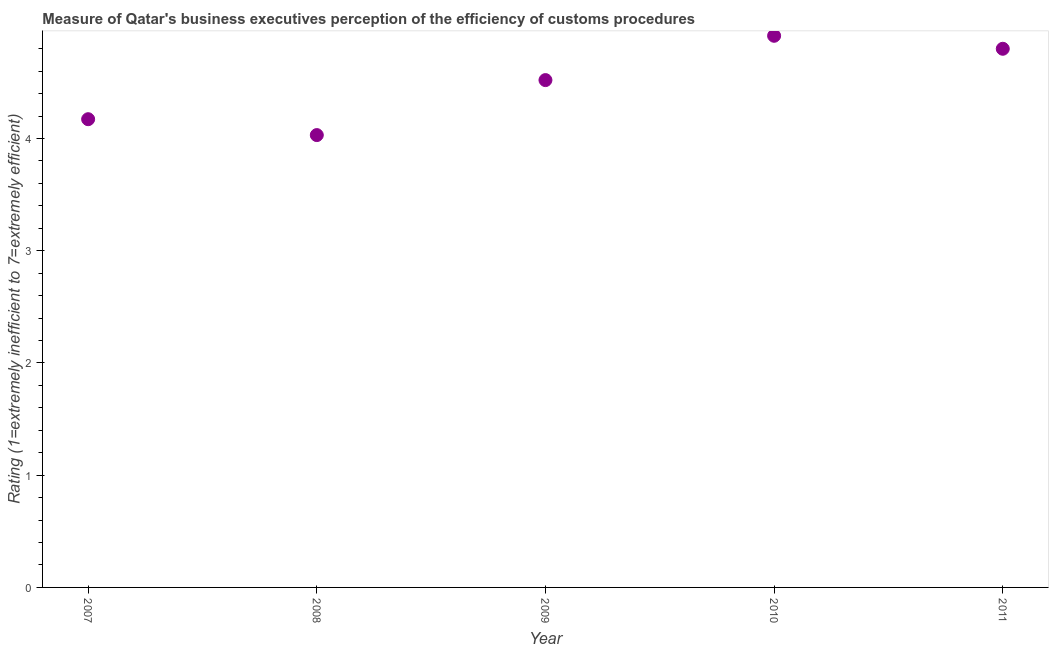What is the rating measuring burden of customs procedure in 2009?
Your answer should be very brief. 4.52. Across all years, what is the maximum rating measuring burden of customs procedure?
Give a very brief answer. 4.92. Across all years, what is the minimum rating measuring burden of customs procedure?
Ensure brevity in your answer.  4.03. In which year was the rating measuring burden of customs procedure minimum?
Keep it short and to the point. 2008. What is the sum of the rating measuring burden of customs procedure?
Ensure brevity in your answer.  22.44. What is the difference between the rating measuring burden of customs procedure in 2007 and 2010?
Provide a succinct answer. -0.74. What is the average rating measuring burden of customs procedure per year?
Give a very brief answer. 4.49. What is the median rating measuring burden of customs procedure?
Provide a succinct answer. 4.52. In how many years, is the rating measuring burden of customs procedure greater than 0.8 ?
Provide a short and direct response. 5. What is the ratio of the rating measuring burden of customs procedure in 2007 to that in 2011?
Keep it short and to the point. 0.87. Is the rating measuring burden of customs procedure in 2009 less than that in 2010?
Your response must be concise. Yes. What is the difference between the highest and the second highest rating measuring burden of customs procedure?
Your answer should be compact. 0.12. Is the sum of the rating measuring burden of customs procedure in 2007 and 2011 greater than the maximum rating measuring burden of customs procedure across all years?
Your answer should be very brief. Yes. What is the difference between the highest and the lowest rating measuring burden of customs procedure?
Your answer should be very brief. 0.88. Does the rating measuring burden of customs procedure monotonically increase over the years?
Keep it short and to the point. No. What is the difference between two consecutive major ticks on the Y-axis?
Offer a very short reply. 1. Are the values on the major ticks of Y-axis written in scientific E-notation?
Make the answer very short. No. Does the graph contain any zero values?
Offer a very short reply. No. Does the graph contain grids?
Give a very brief answer. No. What is the title of the graph?
Provide a succinct answer. Measure of Qatar's business executives perception of the efficiency of customs procedures. What is the label or title of the Y-axis?
Provide a short and direct response. Rating (1=extremely inefficient to 7=extremely efficient). What is the Rating (1=extremely inefficient to 7=extremely efficient) in 2007?
Give a very brief answer. 4.17. What is the Rating (1=extremely inefficient to 7=extremely efficient) in 2008?
Keep it short and to the point. 4.03. What is the Rating (1=extremely inefficient to 7=extremely efficient) in 2009?
Make the answer very short. 4.52. What is the Rating (1=extremely inefficient to 7=extremely efficient) in 2010?
Your answer should be compact. 4.92. What is the difference between the Rating (1=extremely inefficient to 7=extremely efficient) in 2007 and 2008?
Offer a terse response. 0.14. What is the difference between the Rating (1=extremely inefficient to 7=extremely efficient) in 2007 and 2009?
Offer a terse response. -0.35. What is the difference between the Rating (1=extremely inefficient to 7=extremely efficient) in 2007 and 2010?
Keep it short and to the point. -0.74. What is the difference between the Rating (1=extremely inefficient to 7=extremely efficient) in 2007 and 2011?
Offer a terse response. -0.63. What is the difference between the Rating (1=extremely inefficient to 7=extremely efficient) in 2008 and 2009?
Provide a short and direct response. -0.49. What is the difference between the Rating (1=extremely inefficient to 7=extremely efficient) in 2008 and 2010?
Give a very brief answer. -0.88. What is the difference between the Rating (1=extremely inefficient to 7=extremely efficient) in 2008 and 2011?
Provide a short and direct response. -0.77. What is the difference between the Rating (1=extremely inefficient to 7=extremely efficient) in 2009 and 2010?
Give a very brief answer. -0.39. What is the difference between the Rating (1=extremely inefficient to 7=extremely efficient) in 2009 and 2011?
Offer a very short reply. -0.28. What is the difference between the Rating (1=extremely inefficient to 7=extremely efficient) in 2010 and 2011?
Offer a terse response. 0.12. What is the ratio of the Rating (1=extremely inefficient to 7=extremely efficient) in 2007 to that in 2008?
Ensure brevity in your answer.  1.03. What is the ratio of the Rating (1=extremely inefficient to 7=extremely efficient) in 2007 to that in 2009?
Ensure brevity in your answer.  0.92. What is the ratio of the Rating (1=extremely inefficient to 7=extremely efficient) in 2007 to that in 2010?
Your response must be concise. 0.85. What is the ratio of the Rating (1=extremely inefficient to 7=extremely efficient) in 2007 to that in 2011?
Your answer should be compact. 0.87. What is the ratio of the Rating (1=extremely inefficient to 7=extremely efficient) in 2008 to that in 2009?
Make the answer very short. 0.89. What is the ratio of the Rating (1=extremely inefficient to 7=extremely efficient) in 2008 to that in 2010?
Make the answer very short. 0.82. What is the ratio of the Rating (1=extremely inefficient to 7=extremely efficient) in 2008 to that in 2011?
Make the answer very short. 0.84. What is the ratio of the Rating (1=extremely inefficient to 7=extremely efficient) in 2009 to that in 2011?
Your response must be concise. 0.94. What is the ratio of the Rating (1=extremely inefficient to 7=extremely efficient) in 2010 to that in 2011?
Give a very brief answer. 1.02. 